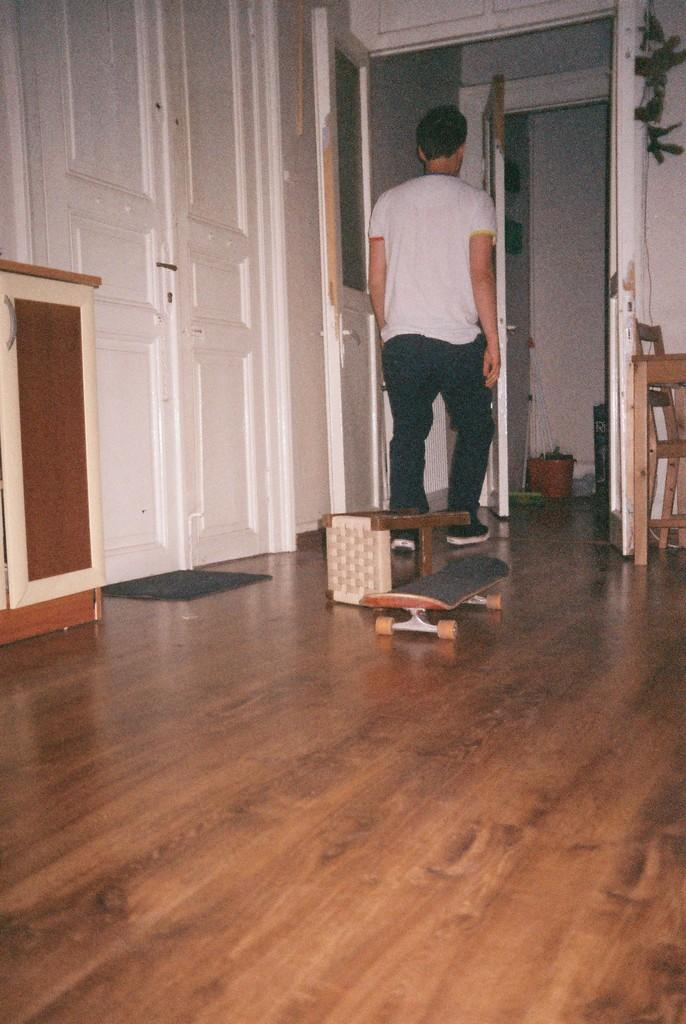What is the main subject in the image? There is a man standing in the image. What object can be seen near the man? There is a stool in the image. What other item is visible in the image? There is a skateboard in the image. What type of prose is being recited by the man in the image? There is no indication in the image that the man is reciting any prose. How does the skateboard compare to the stool in terms of size? The image does not provide any information about the size of the skateboard or the stool, so it is not possible to make a comparison. 